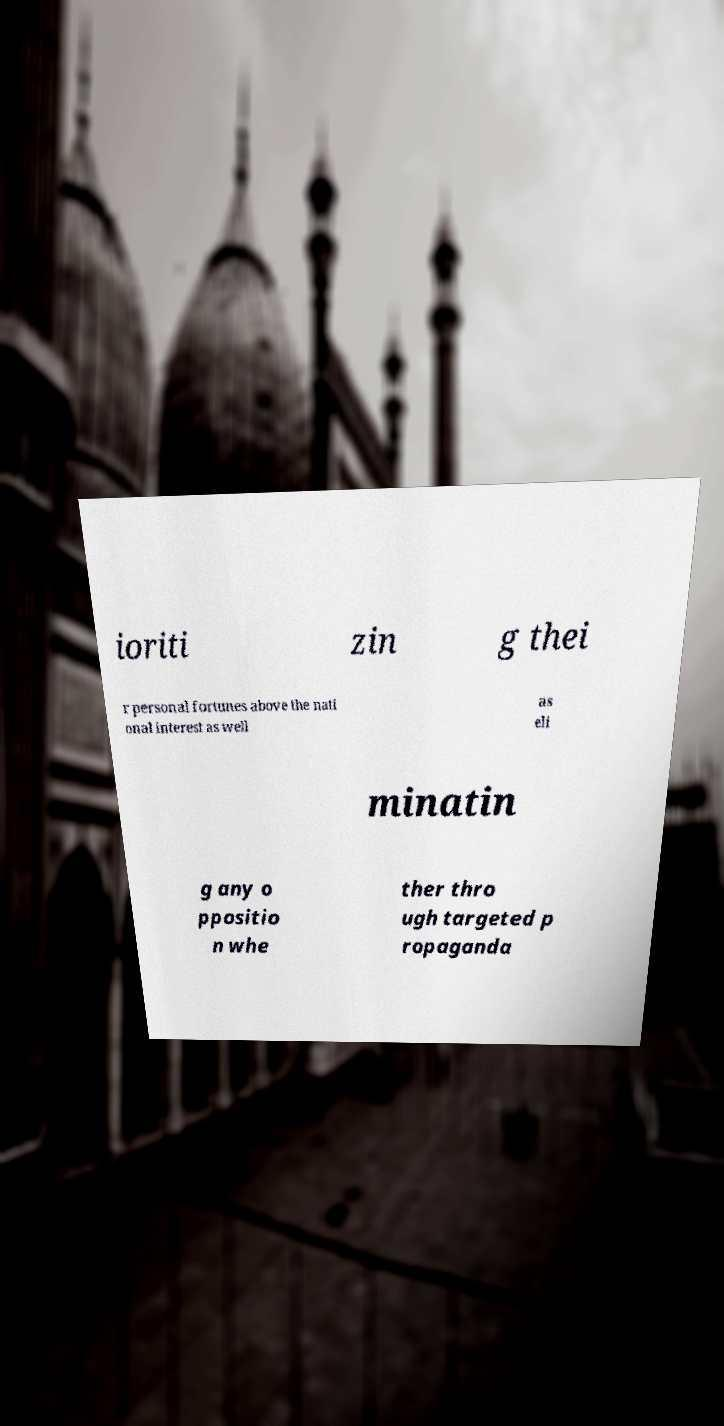Could you extract and type out the text from this image? ioriti zin g thei r personal fortunes above the nati onal interest as well as eli minatin g any o ppositio n whe ther thro ugh targeted p ropaganda 